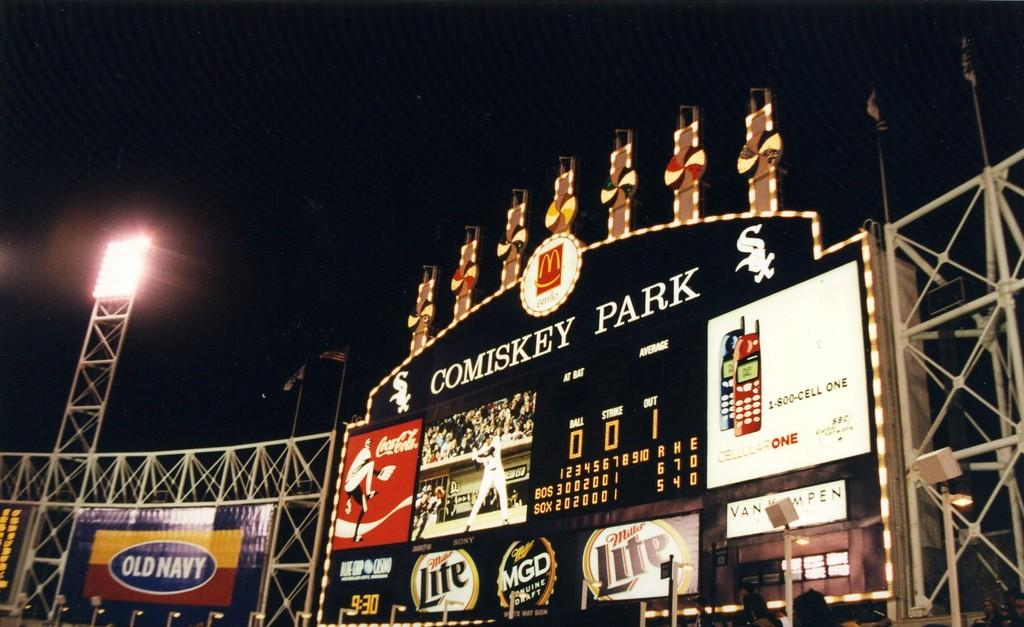<image>
Write a terse but informative summary of the picture. The score board at Comiskey Park has an ad for cell phones on it. 